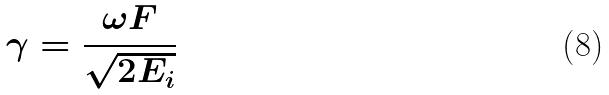Convert formula to latex. <formula><loc_0><loc_0><loc_500><loc_500>\gamma = \frac { \omega F } { \sqrt { 2 E _ { i } } }</formula> 